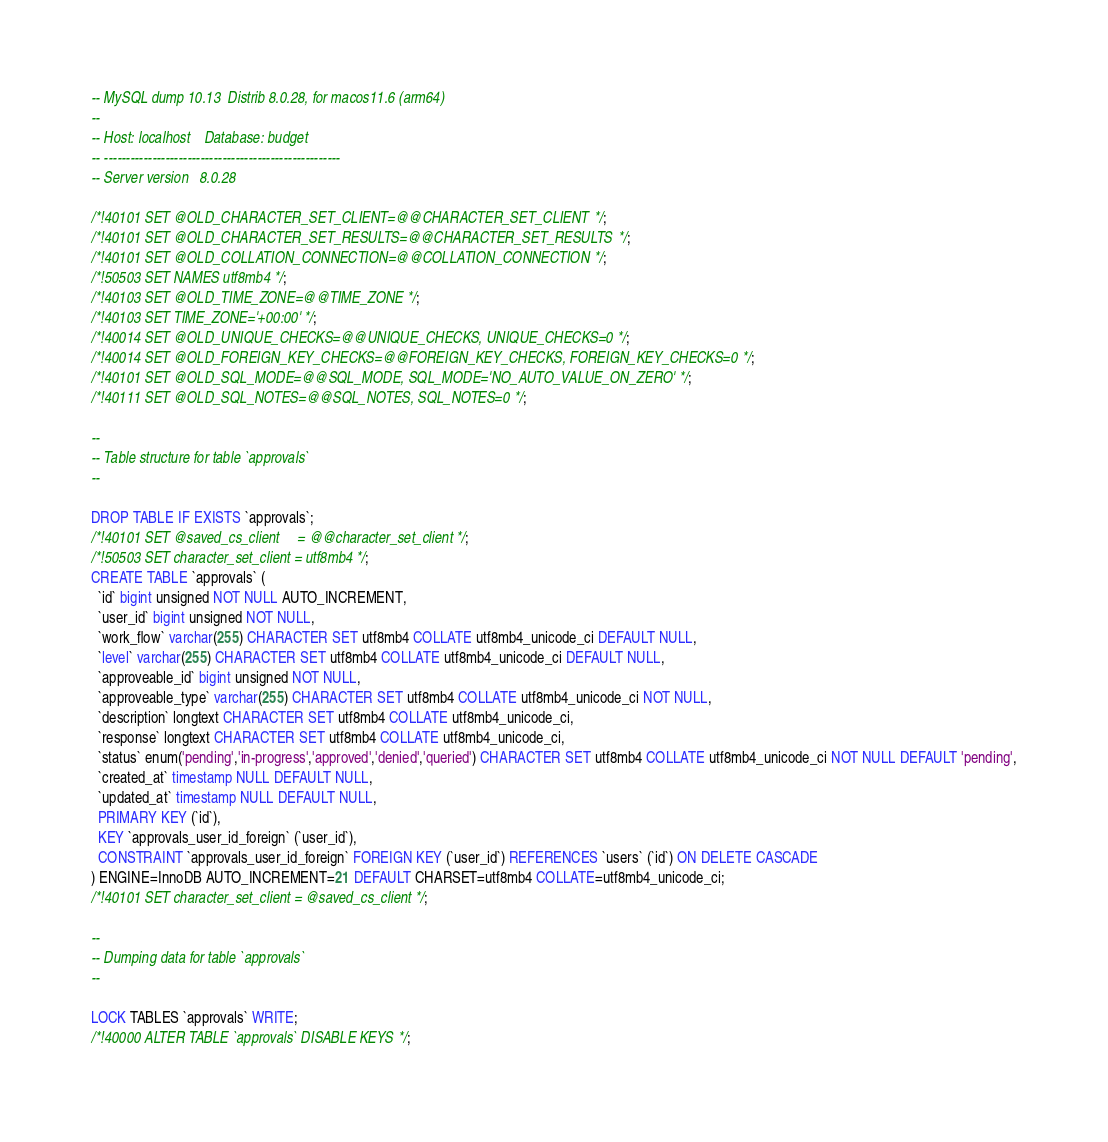<code> <loc_0><loc_0><loc_500><loc_500><_SQL_>-- MySQL dump 10.13  Distrib 8.0.28, for macos11.6 (arm64)
--
-- Host: localhost    Database: budget
-- ------------------------------------------------------
-- Server version	8.0.28

/*!40101 SET @OLD_CHARACTER_SET_CLIENT=@@CHARACTER_SET_CLIENT */;
/*!40101 SET @OLD_CHARACTER_SET_RESULTS=@@CHARACTER_SET_RESULTS */;
/*!40101 SET @OLD_COLLATION_CONNECTION=@@COLLATION_CONNECTION */;
/*!50503 SET NAMES utf8mb4 */;
/*!40103 SET @OLD_TIME_ZONE=@@TIME_ZONE */;
/*!40103 SET TIME_ZONE='+00:00' */;
/*!40014 SET @OLD_UNIQUE_CHECKS=@@UNIQUE_CHECKS, UNIQUE_CHECKS=0 */;
/*!40014 SET @OLD_FOREIGN_KEY_CHECKS=@@FOREIGN_KEY_CHECKS, FOREIGN_KEY_CHECKS=0 */;
/*!40101 SET @OLD_SQL_MODE=@@SQL_MODE, SQL_MODE='NO_AUTO_VALUE_ON_ZERO' */;
/*!40111 SET @OLD_SQL_NOTES=@@SQL_NOTES, SQL_NOTES=0 */;

--
-- Table structure for table `approvals`
--

DROP TABLE IF EXISTS `approvals`;
/*!40101 SET @saved_cs_client     = @@character_set_client */;
/*!50503 SET character_set_client = utf8mb4 */;
CREATE TABLE `approvals` (
  `id` bigint unsigned NOT NULL AUTO_INCREMENT,
  `user_id` bigint unsigned NOT NULL,
  `work_flow` varchar(255) CHARACTER SET utf8mb4 COLLATE utf8mb4_unicode_ci DEFAULT NULL,
  `level` varchar(255) CHARACTER SET utf8mb4 COLLATE utf8mb4_unicode_ci DEFAULT NULL,
  `approveable_id` bigint unsigned NOT NULL,
  `approveable_type` varchar(255) CHARACTER SET utf8mb4 COLLATE utf8mb4_unicode_ci NOT NULL,
  `description` longtext CHARACTER SET utf8mb4 COLLATE utf8mb4_unicode_ci,
  `response` longtext CHARACTER SET utf8mb4 COLLATE utf8mb4_unicode_ci,
  `status` enum('pending','in-progress','approved','denied','queried') CHARACTER SET utf8mb4 COLLATE utf8mb4_unicode_ci NOT NULL DEFAULT 'pending',
  `created_at` timestamp NULL DEFAULT NULL,
  `updated_at` timestamp NULL DEFAULT NULL,
  PRIMARY KEY (`id`),
  KEY `approvals_user_id_foreign` (`user_id`),
  CONSTRAINT `approvals_user_id_foreign` FOREIGN KEY (`user_id`) REFERENCES `users` (`id`) ON DELETE CASCADE
) ENGINE=InnoDB AUTO_INCREMENT=21 DEFAULT CHARSET=utf8mb4 COLLATE=utf8mb4_unicode_ci;
/*!40101 SET character_set_client = @saved_cs_client */;

--
-- Dumping data for table `approvals`
--

LOCK TABLES `approvals` WRITE;
/*!40000 ALTER TABLE `approvals` DISABLE KEYS */;</code> 